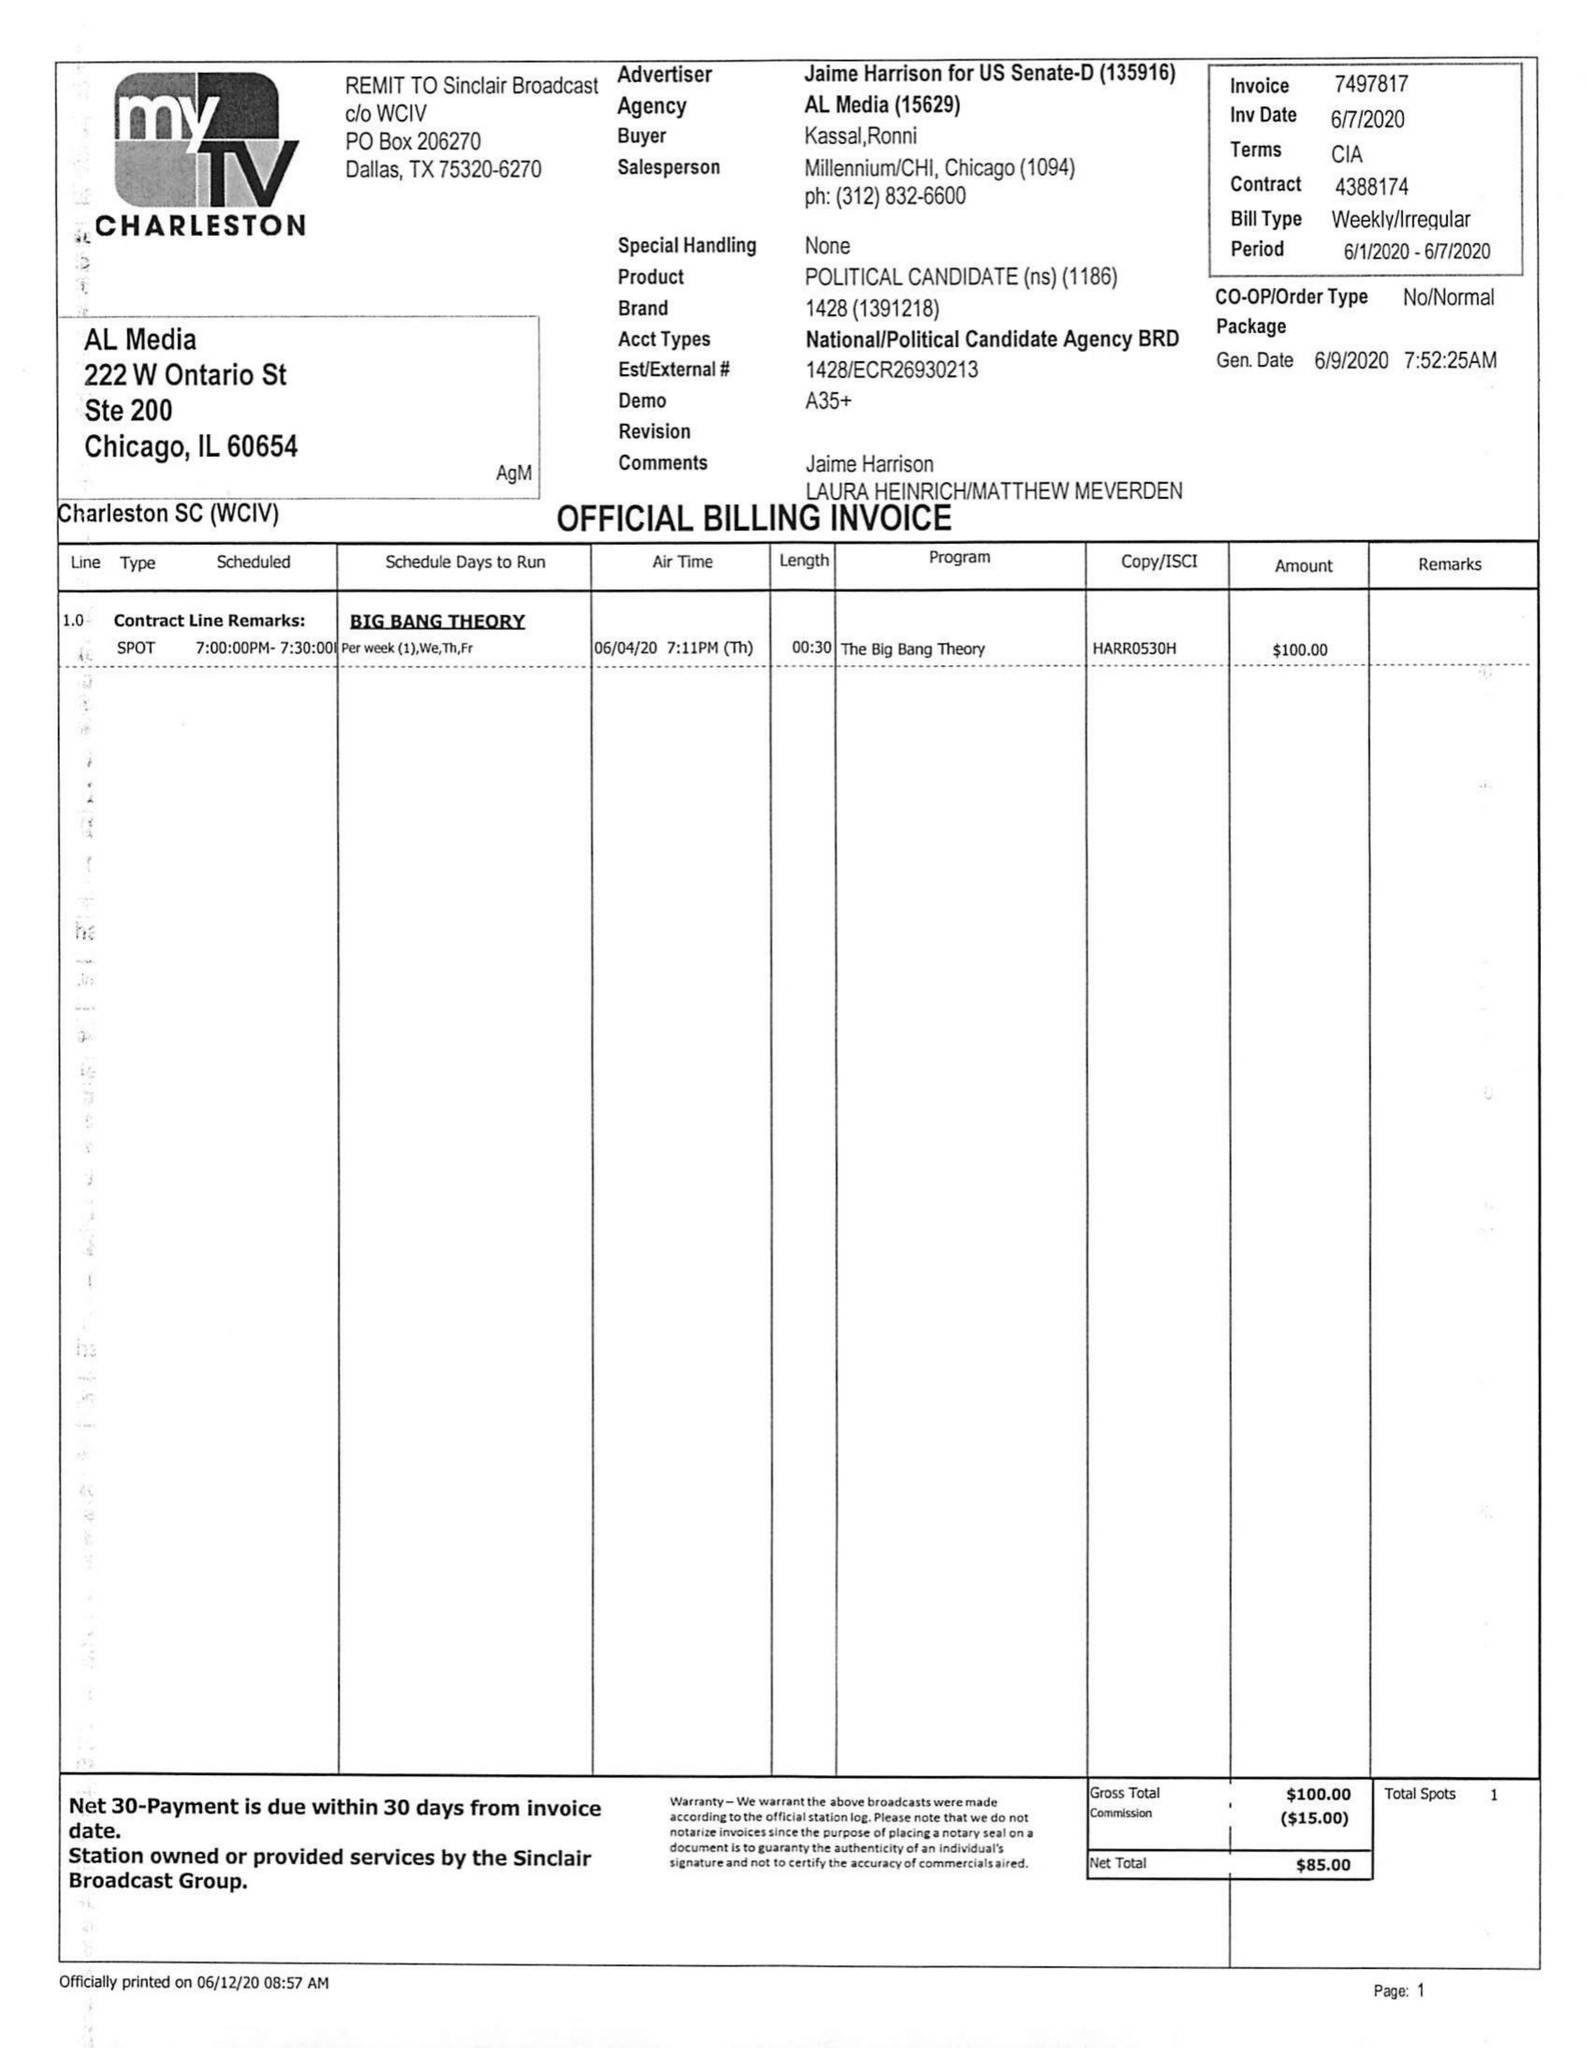What is the value for the flight_to?
Answer the question using a single word or phrase. 06/07/20 